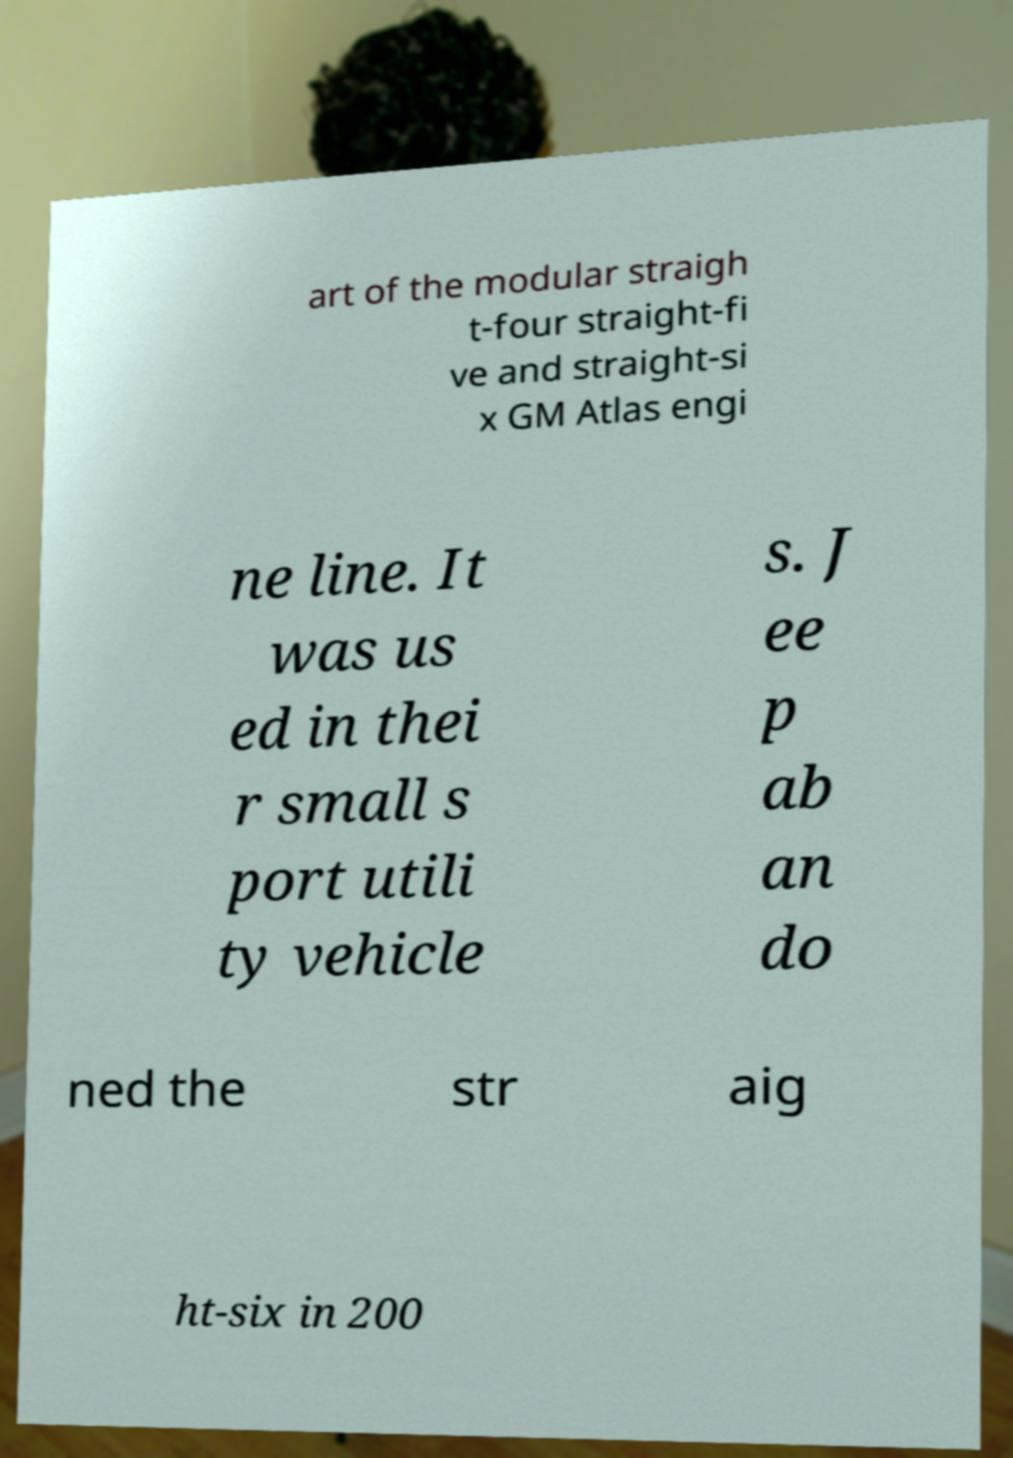Can you read and provide the text displayed in the image?This photo seems to have some interesting text. Can you extract and type it out for me? art of the modular straigh t-four straight-fi ve and straight-si x GM Atlas engi ne line. It was us ed in thei r small s port utili ty vehicle s. J ee p ab an do ned the str aig ht-six in 200 